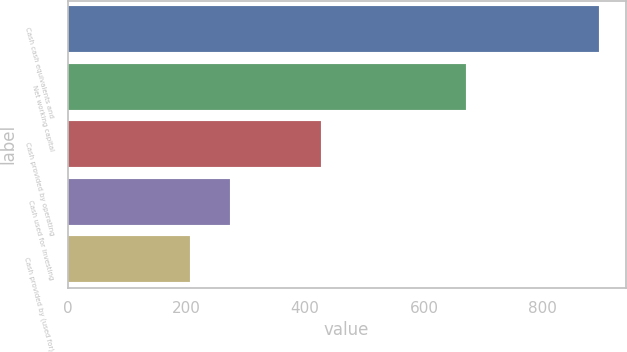Convert chart to OTSL. <chart><loc_0><loc_0><loc_500><loc_500><bar_chart><fcel>Cash cash equivalents and<fcel>Net working capital<fcel>Cash provided by operating<fcel>Cash used for investing<fcel>Cash provided by (used for)<nl><fcel>894.6<fcel>670.5<fcel>426.3<fcel>274.23<fcel>205.3<nl></chart> 